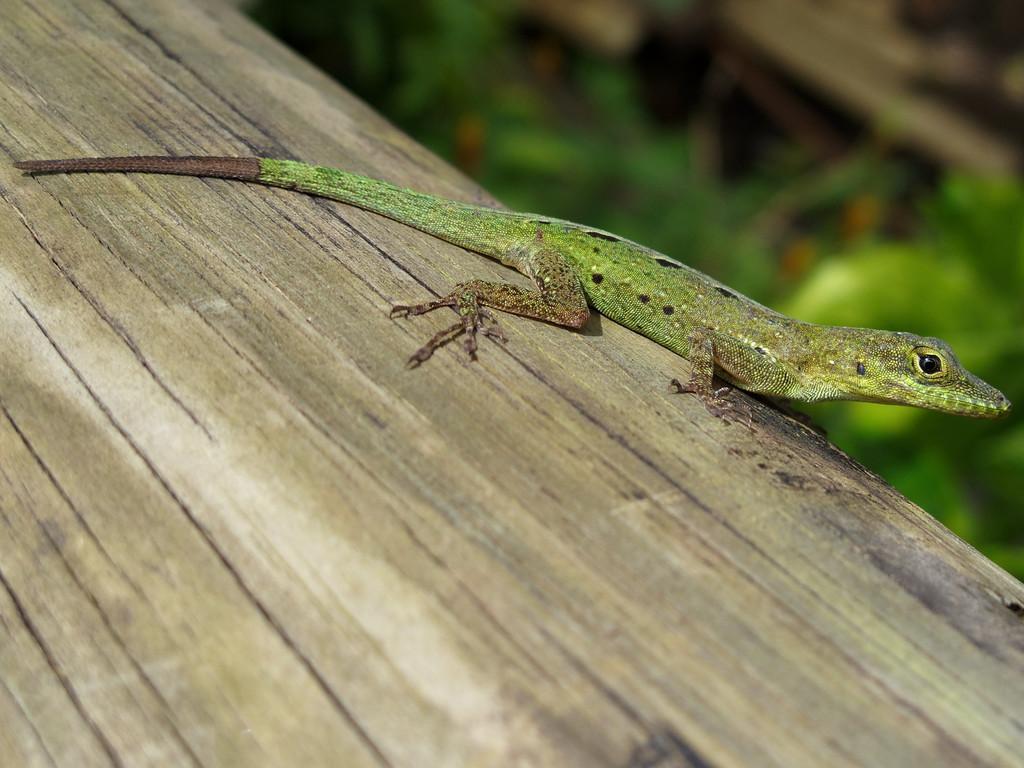Could you give a brief overview of what you see in this image? In this image I can see a lizard on the wood. In the background I can see plants. This image is taken may be during a day. 